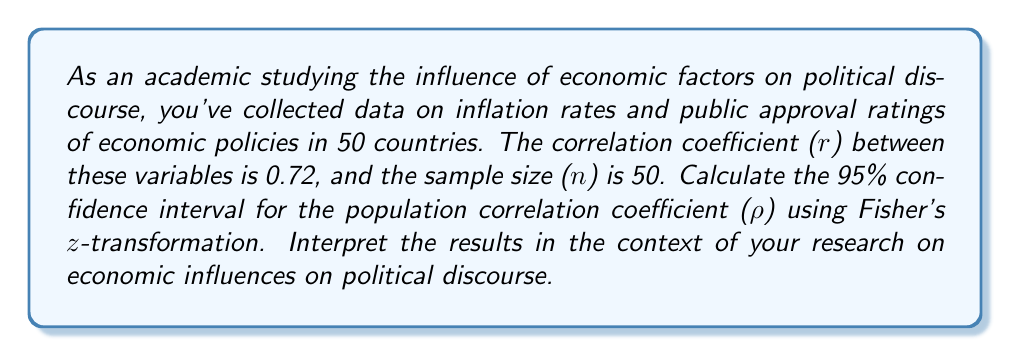Teach me how to tackle this problem. To calculate the confidence interval for the population correlation coefficient (ρ), we'll use Fisher's z-transformation. This method involves several steps:

1. Transform the sample correlation coefficient (r) to z using Fisher's z-transformation:
   $$z = \frac{1}{2} \ln\left(\frac{1+r}{1-r}\right)$$
   $$z = \frac{1}{2} \ln\left(\frac{1+0.72}{1-0.72}\right) = 0.908$$

2. Calculate the standard error of z:
   $$SE_z = \frac{1}{\sqrt{n-3}}$$
   $$SE_z = \frac{1}{\sqrt{50-3}} = 0.149$$

3. Determine the z-score for a 95% confidence interval:
   For a 95% CI, z-score = 1.96

4. Calculate the confidence interval for z:
   $$CI_z = z \pm (z\text{-score} \times SE_z)$$
   $$CI_z = 0.908 \pm (1.96 \times 0.149)$$
   $$CI_z = [0.616, 1.200]$$

5. Transform the CI limits back to r using the inverse of Fisher's z-transformation:
   $$r = \frac{e^{2z} - 1}{e^{2z} + 1}$$
   Lower limit: $r_L = \frac{e^{2(0.616)} - 1}{e^{2(0.616)} + 1} = 0.548$
   Upper limit: $r_U = \frac{e^{2(1.200)} - 1}{e^{2(1.200)} + 1} = 0.834$

Therefore, the 95% confidence interval for the population correlation coefficient (ρ) is [0.548, 0.834].

Interpretation: We can be 95% confident that the true population correlation coefficient between inflation rates and public approval of economic policies falls between 0.548 and 0.834. This strong positive correlation supports the argument that economic factors have a significant influence on political discourse, as changes in inflation rates are associated with changes in public approval of economic policies.
Answer: 95% CI for ρ: [0.548, 0.834] 